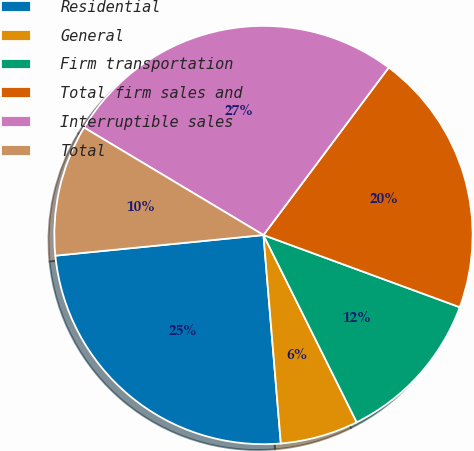<chart> <loc_0><loc_0><loc_500><loc_500><pie_chart><fcel>Residential<fcel>General<fcel>Firm transportation<fcel>Total firm sales and<fcel>Interruptible sales<fcel>Total<nl><fcel>24.75%<fcel>6.03%<fcel>12.04%<fcel>20.39%<fcel>26.63%<fcel>10.16%<nl></chart> 